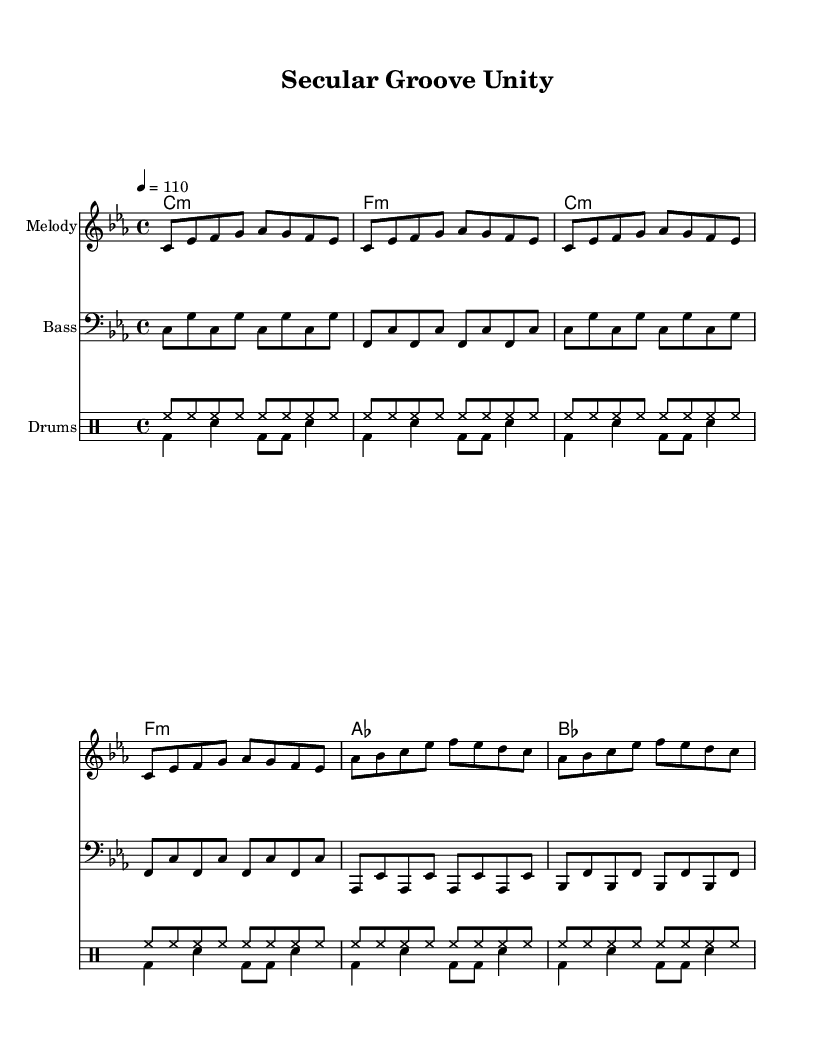What is the key signature of this music? The key signature is C minor, which has three flats (B flat, E flat, and A flat). This can be identified from the key signature indicated at the beginning of the sheet music.
Answer: C minor What is the time signature of this piece? The time signature is 4/4, which means there are four beats in each measure and a quarter note gets one beat. This is visually indicated at the start of the sheet music.
Answer: 4/4 What is the tempo marking for this music? The tempo marking is specified as quarter note equals 110 beats per minute (notated as 4 = 110). This indicates the speed of the piece.
Answer: 110 What is the structure of the main sections in the song? The structure consists of an Intro, Verse, and Chorus, each played twice. This can be determined by the labeled sections in the sheet music.
Answer: Intro, Verse, Chorus Which instrument plays the melody? The melody is played by the treble staff, which is labeled "Melody" in the score. This identifies the instrument intended to perform the melody line.
Answer: Melody How many measures are in the Chorus section? The Chorus section contains four measures. By counting the measures in the chorus part of the music, two measures from each round of repetition can be noted.
Answer: 4 What type of rhythm is used primarily in the drums? The primary rhythm in the drums consists of a combination of hi-hat and snare patterns, characterized by consistent eighth notes and a syncopated kick drum pattern. This is typical in Funk music to create a rhythmic groove.
Answer: Funk rhythm 